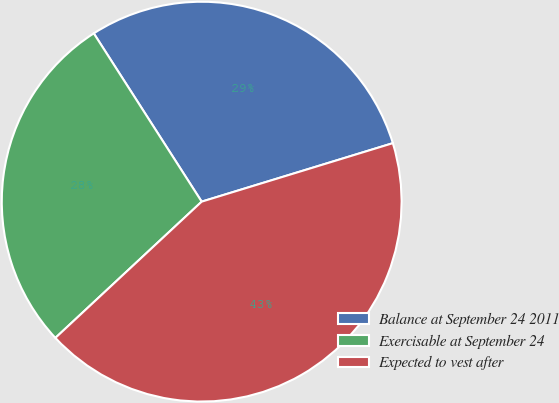<chart> <loc_0><loc_0><loc_500><loc_500><pie_chart><fcel>Balance at September 24 2011<fcel>Exercisable at September 24<fcel>Expected to vest after<nl><fcel>29.35%<fcel>27.86%<fcel>42.79%<nl></chart> 